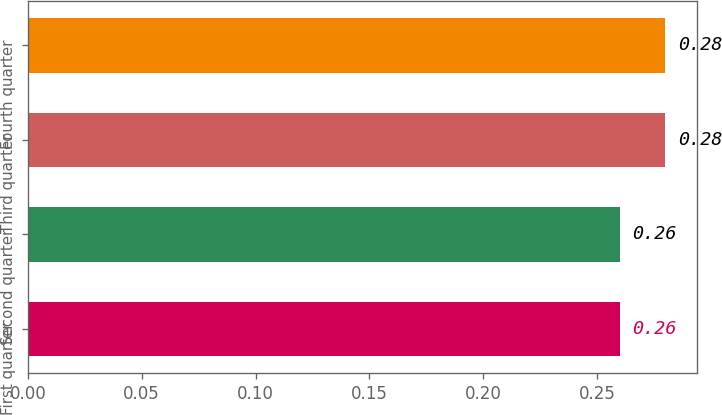Convert chart to OTSL. <chart><loc_0><loc_0><loc_500><loc_500><bar_chart><fcel>First quarter<fcel>Second quarter<fcel>Third quarter<fcel>Fourth quarter<nl><fcel>0.26<fcel>0.26<fcel>0.28<fcel>0.28<nl></chart> 